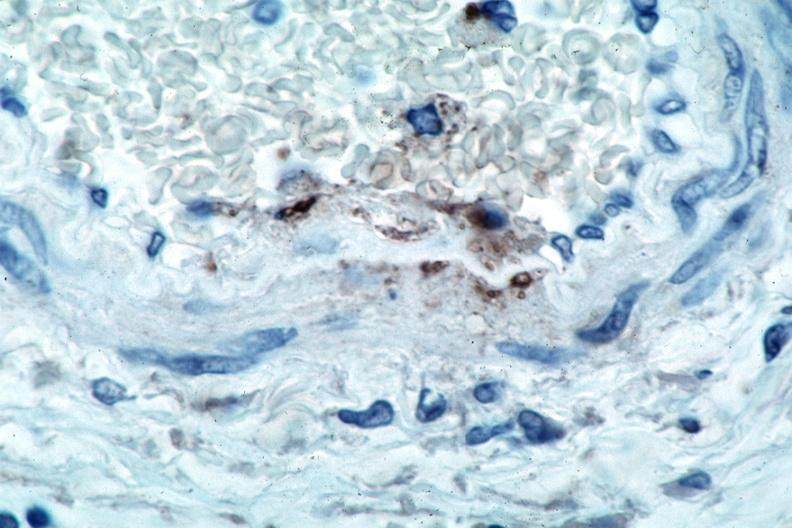does this image show vasculitis?
Answer the question using a single word or phrase. Yes 